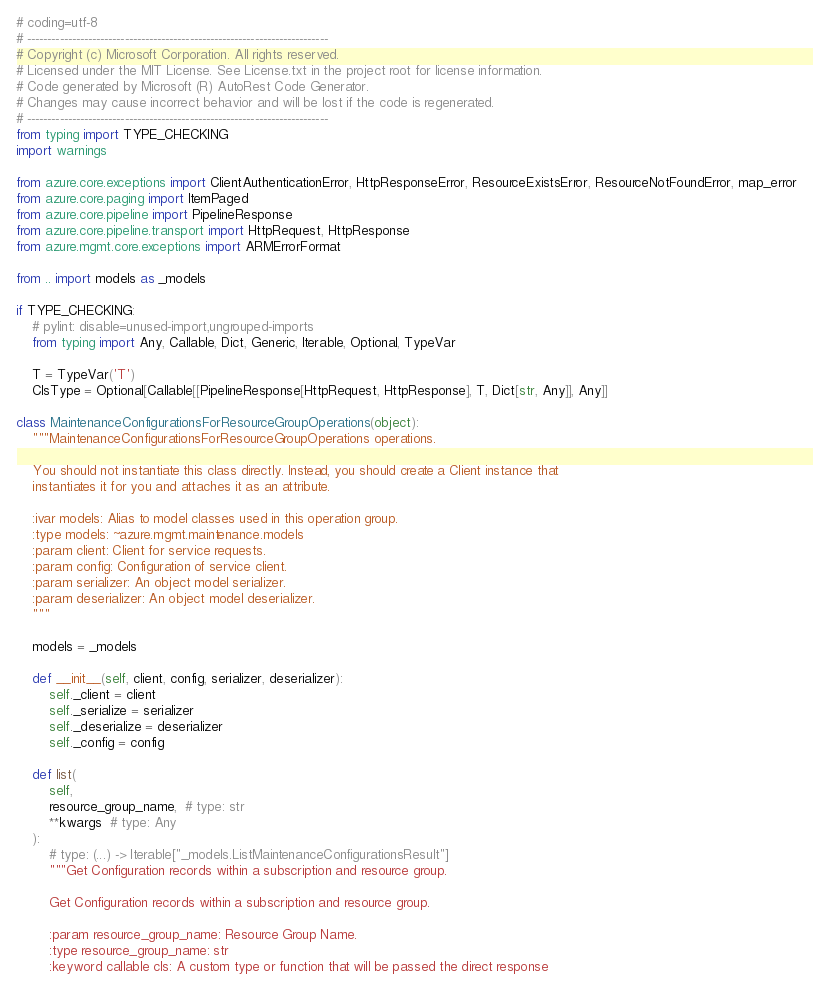<code> <loc_0><loc_0><loc_500><loc_500><_Python_># coding=utf-8
# --------------------------------------------------------------------------
# Copyright (c) Microsoft Corporation. All rights reserved.
# Licensed under the MIT License. See License.txt in the project root for license information.
# Code generated by Microsoft (R) AutoRest Code Generator.
# Changes may cause incorrect behavior and will be lost if the code is regenerated.
# --------------------------------------------------------------------------
from typing import TYPE_CHECKING
import warnings

from azure.core.exceptions import ClientAuthenticationError, HttpResponseError, ResourceExistsError, ResourceNotFoundError, map_error
from azure.core.paging import ItemPaged
from azure.core.pipeline import PipelineResponse
from azure.core.pipeline.transport import HttpRequest, HttpResponse
from azure.mgmt.core.exceptions import ARMErrorFormat

from .. import models as _models

if TYPE_CHECKING:
    # pylint: disable=unused-import,ungrouped-imports
    from typing import Any, Callable, Dict, Generic, Iterable, Optional, TypeVar

    T = TypeVar('T')
    ClsType = Optional[Callable[[PipelineResponse[HttpRequest, HttpResponse], T, Dict[str, Any]], Any]]

class MaintenanceConfigurationsForResourceGroupOperations(object):
    """MaintenanceConfigurationsForResourceGroupOperations operations.

    You should not instantiate this class directly. Instead, you should create a Client instance that
    instantiates it for you and attaches it as an attribute.

    :ivar models: Alias to model classes used in this operation group.
    :type models: ~azure.mgmt.maintenance.models
    :param client: Client for service requests.
    :param config: Configuration of service client.
    :param serializer: An object model serializer.
    :param deserializer: An object model deserializer.
    """

    models = _models

    def __init__(self, client, config, serializer, deserializer):
        self._client = client
        self._serialize = serializer
        self._deserialize = deserializer
        self._config = config

    def list(
        self,
        resource_group_name,  # type: str
        **kwargs  # type: Any
    ):
        # type: (...) -> Iterable["_models.ListMaintenanceConfigurationsResult"]
        """Get Configuration records within a subscription and resource group.

        Get Configuration records within a subscription and resource group.

        :param resource_group_name: Resource Group Name.
        :type resource_group_name: str
        :keyword callable cls: A custom type or function that will be passed the direct response</code> 